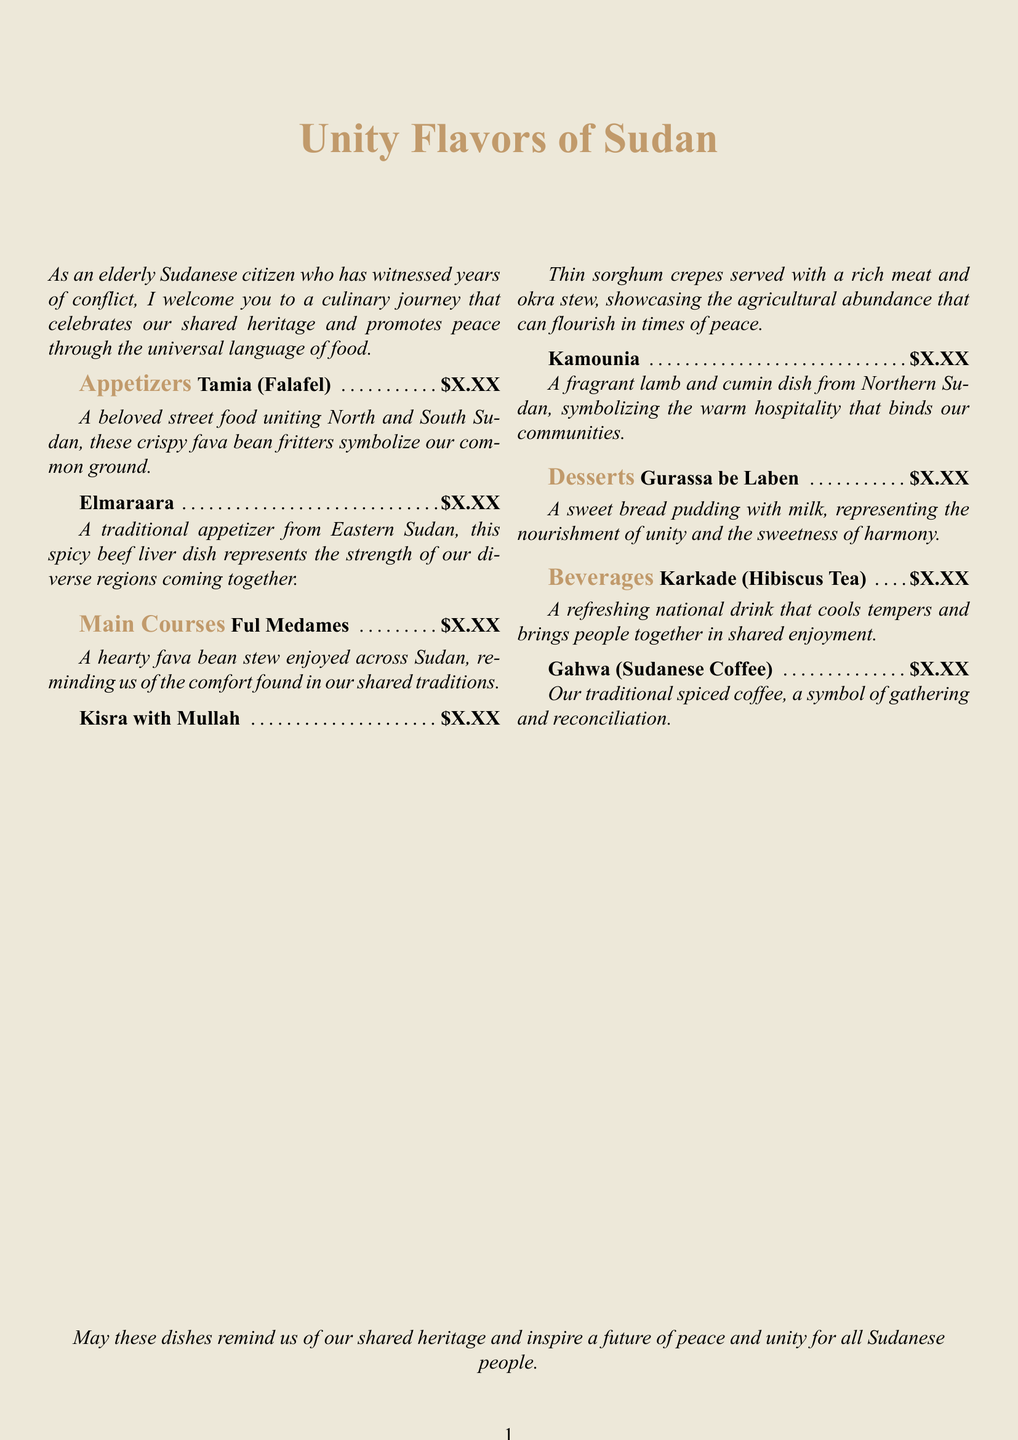What is the title of the menu? The title is prominently displayed at the top of the document and indicates the theme of the menu, which focuses on unity.
Answer: Unity Flavors of Sudan What dish symbolizes our common ground? A specific appetizer that brings together different regions of Sudan and signifies unity and commonality is mentioned.
Answer: Tamia (Falafel) Which beverage is a symbol of gathering? The menu highlights a drink known for its association with communal gatherings, making it a part of the shared experience.
Answer: Gahwa (Sudanese Coffee) What main course showcases agricultural abundance? The menu describes a dish that highlights the agricultural resources and emphasizes peace among communities through shared food.
Answer: Kisra with Mullah What is the description of Gurassa be Laben? The dessert's description emphasizes its symbolism related to unity and nourishment, drawing from cultural traditions.
Answer: A sweet bread pudding with milk, representing the nourishment of unity and the sweetness of harmony How many appetizers are listed? By counting the items in the appetizers section, one can determine the total number of appetizers included in the menu.
Answer: 2 What type of tea is featured in the beverages? A specific herbal drink is mentioned that is refreshing and symbolizes unity among the people.
Answer: Karkade (Hibiscus Tea) Which dish represents the strength of diverse regions? The menu notes that a particular traditional appetizer reflects the unification of various regions, emphasizing their strength together.
Answer: Elmaraara What is the primary ingredient in Ful Medames? The main component of this popular stew is highlighted, showcasing a common food item in Sudanese cuisine.
Answer: Fava beans 